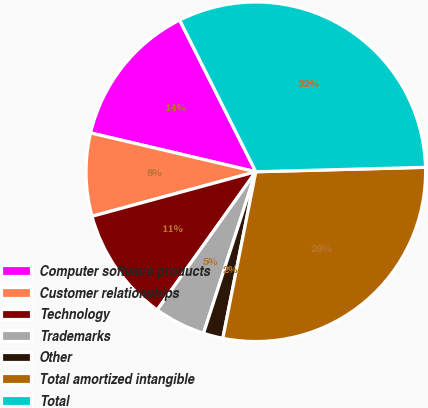Convert chart. <chart><loc_0><loc_0><loc_500><loc_500><pie_chart><fcel>Computer software products<fcel>Customer relationships<fcel>Technology<fcel>Trademarks<fcel>Other<fcel>Total amortized intangible<fcel>Total<nl><fcel>13.92%<fcel>7.9%<fcel>10.91%<fcel>4.88%<fcel>1.87%<fcel>28.53%<fcel>31.99%<nl></chart> 